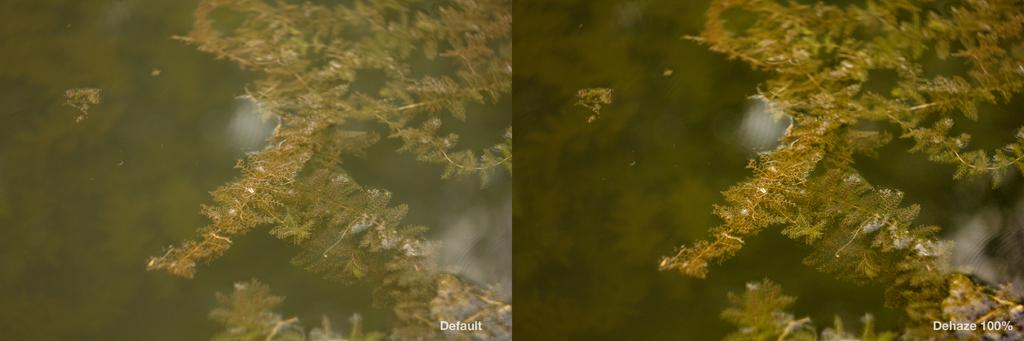What is the primary element visible in the image? There is water in the image. Are there any plants or flowers present in the water? Yes, there are wildflowers in the water. How does the clam move around in the image? There is no clam present in the image, so it cannot move around. 